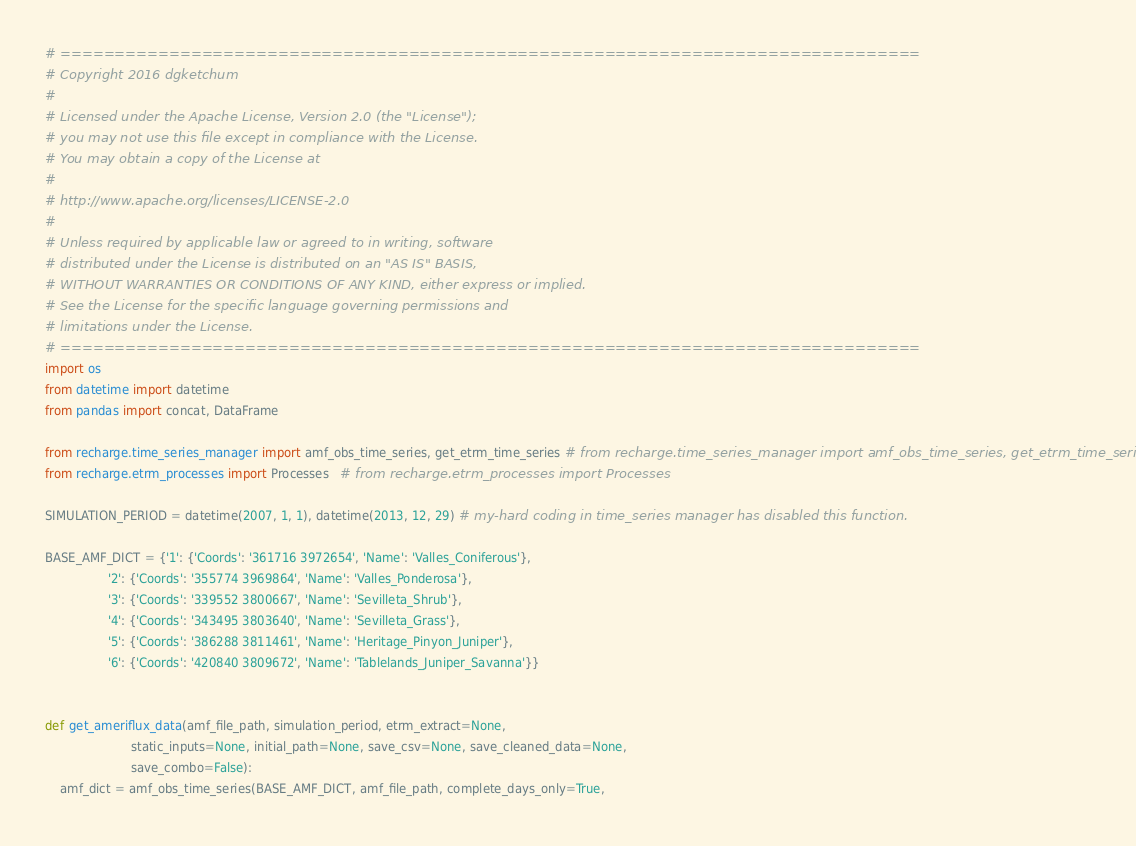Convert code to text. <code><loc_0><loc_0><loc_500><loc_500><_Python_># ===============================================================================
# Copyright 2016 dgketchum
#
# Licensed under the Apache License, Version 2.0 (the "License");
# you may not use this file except in compliance with the License.
# You may obtain a copy of the License at
#
# http://www.apache.org/licenses/LICENSE-2.0
#
# Unless required by applicable law or agreed to in writing, software
# distributed under the License is distributed on an "AS IS" BASIS,
# WITHOUT WARRANTIES OR CONDITIONS OF ANY KIND, either express or implied.
# See the License for the specific language governing permissions and
# limitations under the License.
# ===============================================================================
import os
from datetime import datetime
from pandas import concat, DataFrame

from recharge.time_series_manager import amf_obs_time_series, get_etrm_time_series # from recharge.time_series_manager import amf_obs_time_series, get_etrm_time_series
from recharge.etrm_processes import Processes   # from recharge.etrm_processes import Processes

SIMULATION_PERIOD = datetime(2007, 1, 1), datetime(2013, 12, 29) # my-hard coding in time_series manager has disabled this function.

BASE_AMF_DICT = {'1': {'Coords': '361716 3972654', 'Name': 'Valles_Coniferous'},
                 '2': {'Coords': '355774 3969864', 'Name': 'Valles_Ponderosa'},
                 '3': {'Coords': '339552 3800667', 'Name': 'Sevilleta_Shrub'},
                 '4': {'Coords': '343495 3803640', 'Name': 'Sevilleta_Grass'},
                 '5': {'Coords': '386288 3811461', 'Name': 'Heritage_Pinyon_Juniper'},
                 '6': {'Coords': '420840 3809672', 'Name': 'Tablelands_Juniper_Savanna'}}


def get_ameriflux_data(amf_file_path, simulation_period, etrm_extract=None,
                       static_inputs=None, initial_path=None, save_csv=None, save_cleaned_data=None,
                       save_combo=False):
    amf_dict = amf_obs_time_series(BASE_AMF_DICT, amf_file_path, complete_days_only=True,</code> 